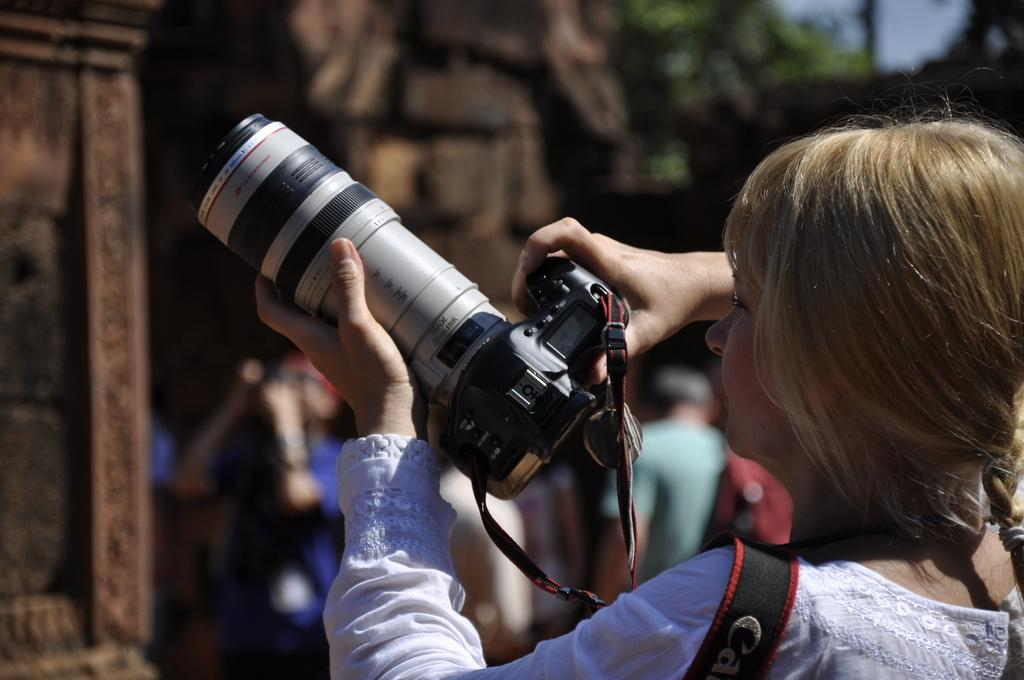What is the main activity of the person in the image? The person in the image is capturing photos. Are there any other people present in the image? Yes, there are a few people in front of the person capturing photos. What can be seen in the background of the image? There is a tree in front of the person capturing photos. What type of knife is the person using to take photos in the image? There is no knife present in the image; the person is using a camera to capture photos. 